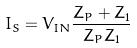Convert formula to latex. <formula><loc_0><loc_0><loc_500><loc_500>I _ { S } = V _ { I N } \frac { Z _ { P } + Z _ { 1 } } { Z _ { P } Z _ { 1 } }</formula> 